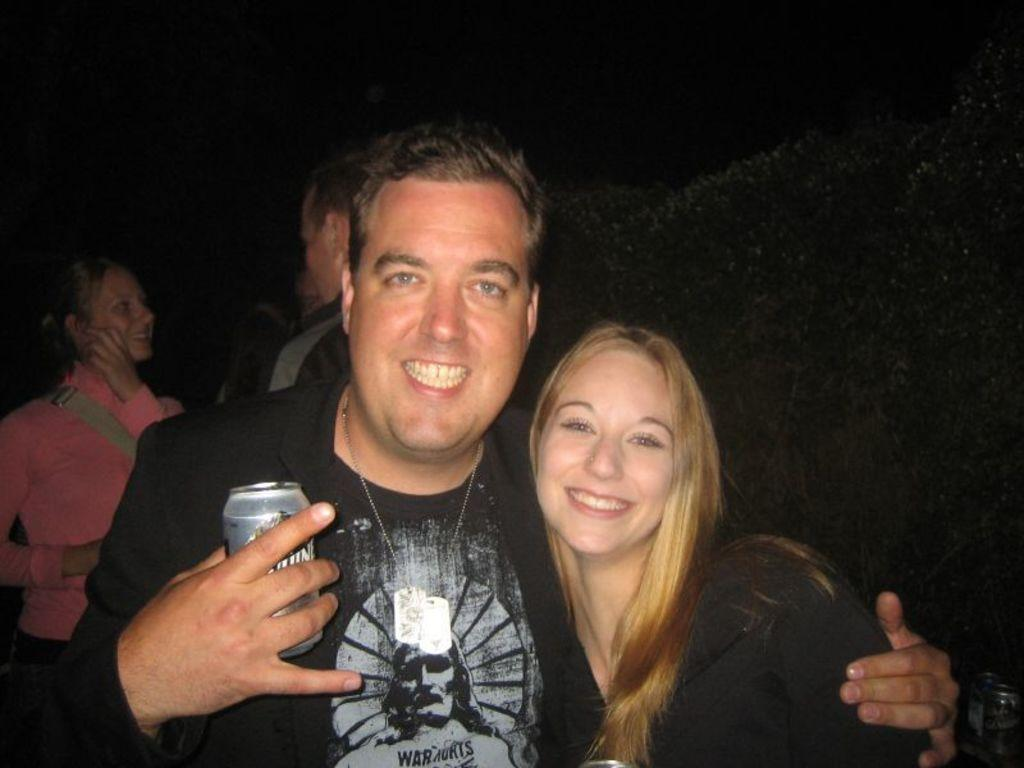How many persons are visible in the image? There are two persons in the image. Can you describe the persons in the front of the image? One of the persons is a man, and the other person is a woman. What are the man and the woman wearing? Both the man and the woman are wearing black dresses. What is the man holding in his hand? The man is holding a tin in his hand. What type of marble is used to decorate the calendar in the image? There is no calendar or marble present in the image. What kind of insurance policy do the persons in the image have? There is no information about insurance policies in the image. 